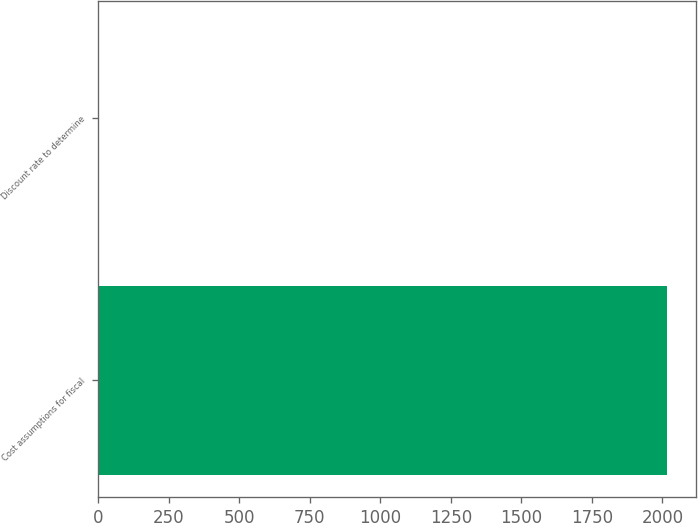<chart> <loc_0><loc_0><loc_500><loc_500><bar_chart><fcel>Cost assumptions for fiscal<fcel>Discount rate to determine<nl><fcel>2018<fcel>3.04<nl></chart> 